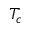Convert formula to latex. <formula><loc_0><loc_0><loc_500><loc_500>T _ { c }</formula> 